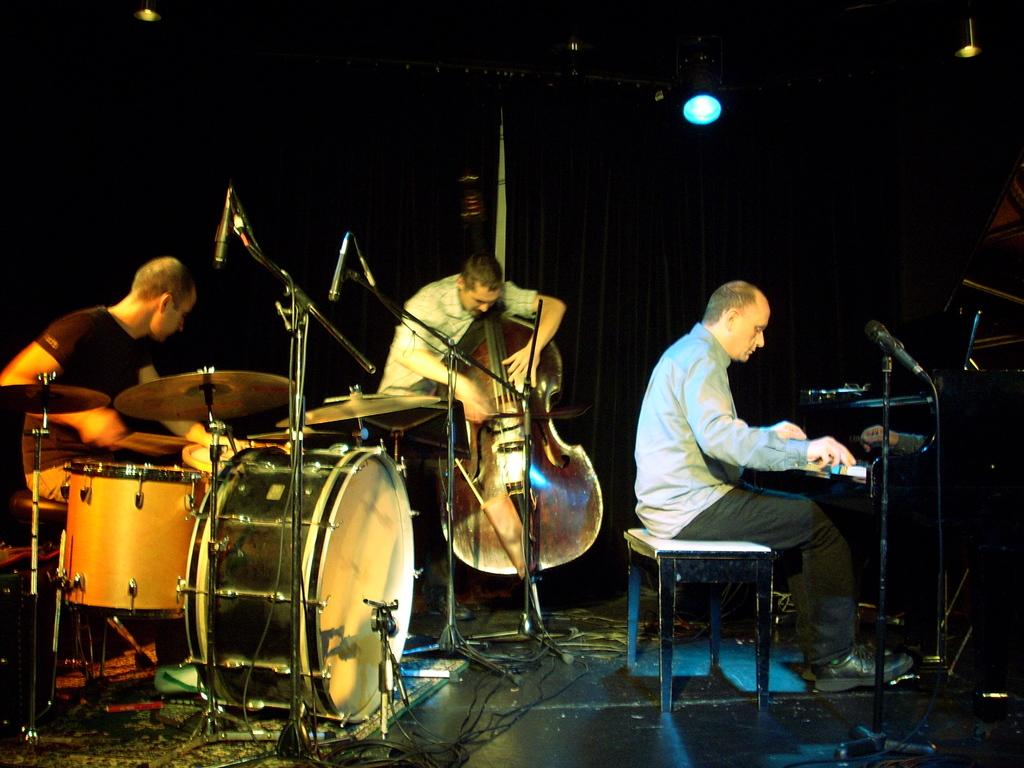What is happening in the image? There is a group of people in the image, and they are playing musical instruments. What are the people in the image doing? The group of people are playing musical instruments. What type of rings can be seen on the hands of the people in the image? There are no rings visible on the hands of the people in the image. What type of war is depicted in the image? There is no war depicted in the image; it features a group of people playing musical instruments. 